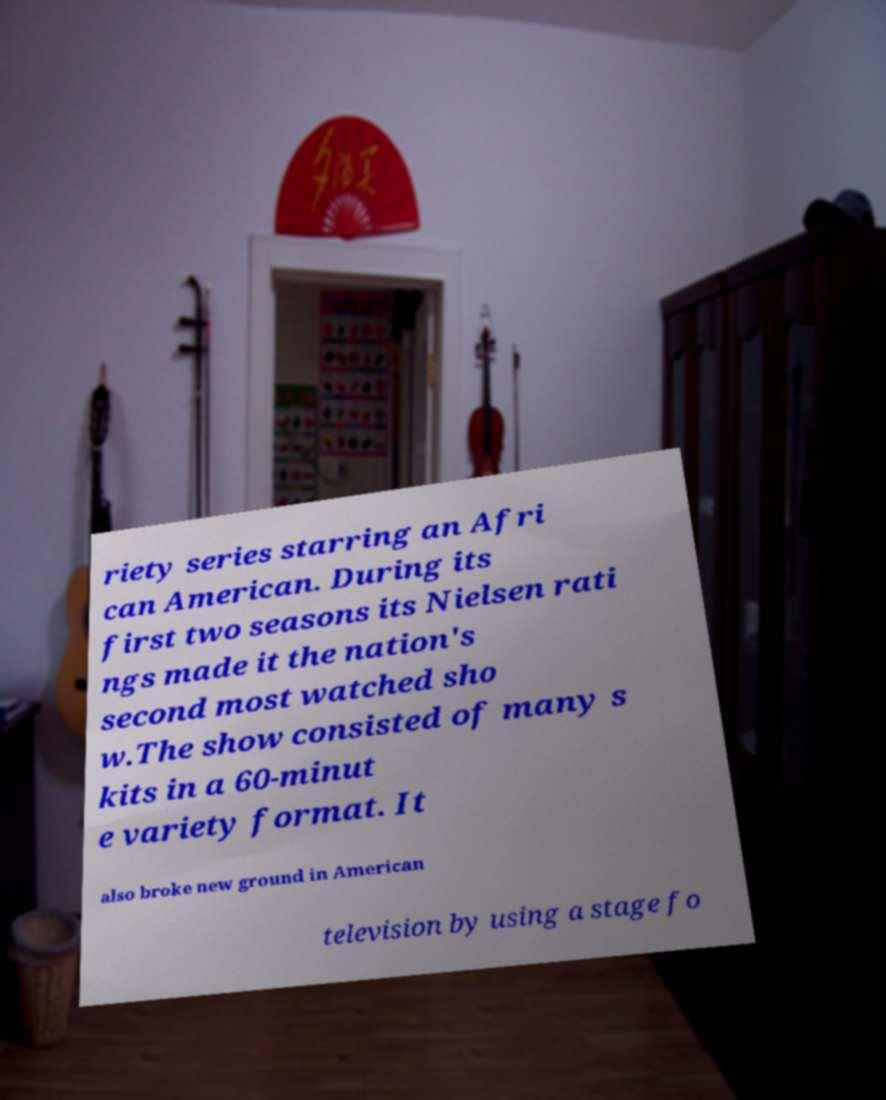Could you extract and type out the text from this image? riety series starring an Afri can American. During its first two seasons its Nielsen rati ngs made it the nation's second most watched sho w.The show consisted of many s kits in a 60-minut e variety format. It also broke new ground in American television by using a stage fo 